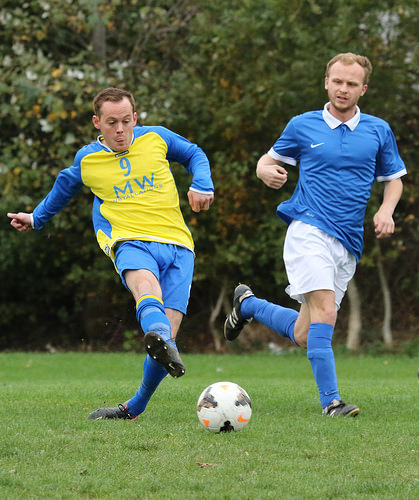<image>
Is there a man to the left of the man? Yes. From this viewpoint, the man is positioned to the left side relative to the man. Is there a man in front of the ball? No. The man is not in front of the ball. The spatial positioning shows a different relationship between these objects. 